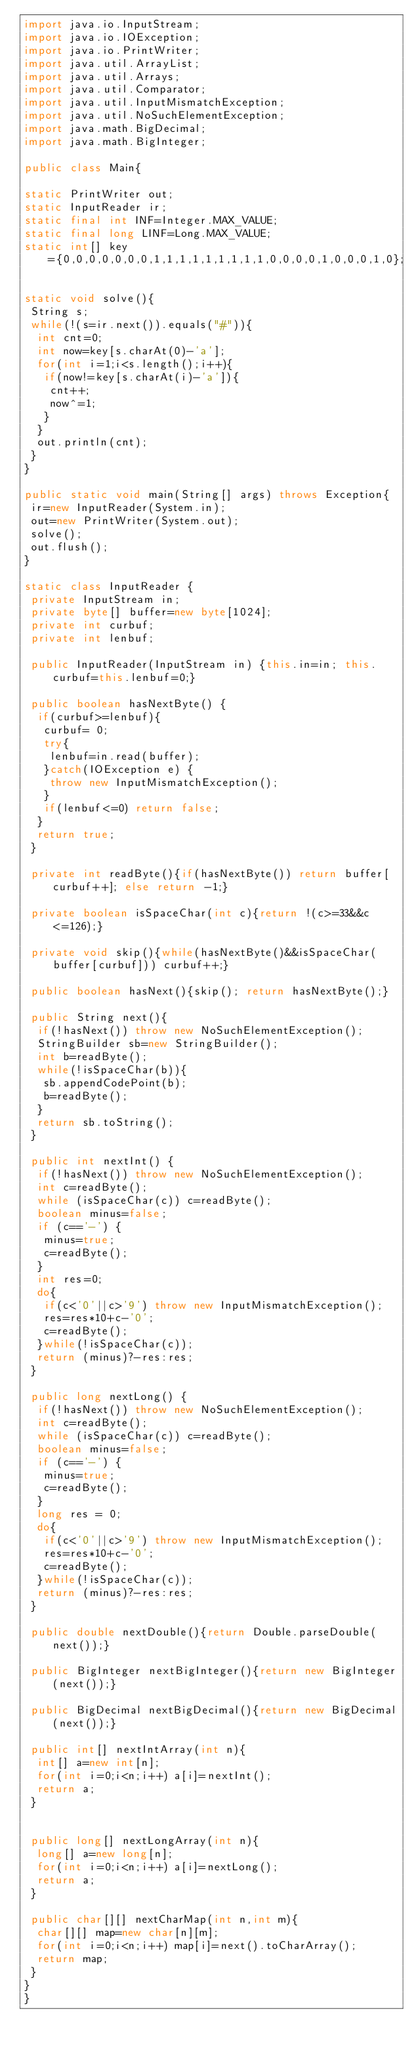Convert code to text. <code><loc_0><loc_0><loc_500><loc_500><_Java_>import java.io.InputStream;
import java.io.IOException;
import java.io.PrintWriter;
import java.util.ArrayList;
import java.util.Arrays;
import java.util.Comparator;
import java.util.InputMismatchException;
import java.util.NoSuchElementException;
import java.math.BigDecimal;
import java.math.BigInteger;
    
public class Main{
 
static PrintWriter out;
static InputReader ir;
static final int INF=Integer.MAX_VALUE;
static final long LINF=Long.MAX_VALUE;
static int[] key={0,0,0,0,0,0,0,1,1,1,1,1,1,1,1,1,0,0,0,0,1,0,0,0,1,0};
 
static void solve(){
 String s;
 while(!(s=ir.next()).equals("#")){
  int cnt=0;
  int now=key[s.charAt(0)-'a'];
  for(int i=1;i<s.length();i++){
   if(now!=key[s.charAt(i)-'a']){
    cnt++;
    now^=1;
   }
  }
  out.println(cnt);
 }
}

public static void main(String[] args) throws Exception{
 ir=new InputReader(System.in);
 out=new PrintWriter(System.out);
 solve();
 out.flush();
}

static class InputReader {
 private InputStream in;
 private byte[] buffer=new byte[1024];
 private int curbuf;
 private int lenbuf;

 public InputReader(InputStream in) {this.in=in; this.curbuf=this.lenbuf=0;}
 
 public boolean hasNextByte() {
  if(curbuf>=lenbuf){
   curbuf= 0;
   try{
    lenbuf=in.read(buffer);
   }catch(IOException e) {
    throw new InputMismatchException();
   }
   if(lenbuf<=0) return false;
  }
  return true;
 }

 private int readByte(){if(hasNextByte()) return buffer[curbuf++]; else return -1;}
 
 private boolean isSpaceChar(int c){return !(c>=33&&c<=126);}
 
 private void skip(){while(hasNextByte()&&isSpaceChar(buffer[curbuf])) curbuf++;}
 
 public boolean hasNext(){skip(); return hasNextByte();}
 
 public String next(){
  if(!hasNext()) throw new NoSuchElementException();
  StringBuilder sb=new StringBuilder();
  int b=readByte();
  while(!isSpaceChar(b)){
   sb.appendCodePoint(b);
   b=readByte();
  }
  return sb.toString();
 }
 
 public int nextInt() {
  if(!hasNext()) throw new NoSuchElementException();
  int c=readByte();
  while (isSpaceChar(c)) c=readByte();
  boolean minus=false;
  if (c=='-') {
   minus=true;
   c=readByte();
  }
  int res=0;
  do{
   if(c<'0'||c>'9') throw new InputMismatchException();
   res=res*10+c-'0';
   c=readByte();
  }while(!isSpaceChar(c));
  return (minus)?-res:res;
 }
 
 public long nextLong() {
  if(!hasNext()) throw new NoSuchElementException();
  int c=readByte();
  while (isSpaceChar(c)) c=readByte();
  boolean minus=false;
  if (c=='-') {
   minus=true;
   c=readByte();
  }
  long res = 0;
  do{
   if(c<'0'||c>'9') throw new InputMismatchException();
   res=res*10+c-'0';
   c=readByte();
  }while(!isSpaceChar(c));
  return (minus)?-res:res;
 }
 
 public double nextDouble(){return Double.parseDouble(next());}
 
 public BigInteger nextBigInteger(){return new BigInteger(next());}
 
 public BigDecimal nextBigDecimal(){return new BigDecimal(next());}
 
 public int[] nextIntArray(int n){
  int[] a=new int[n];
  for(int i=0;i<n;i++) a[i]=nextInt();
  return a;
 }
 
 
 public long[] nextLongArray(int n){
  long[] a=new long[n];
  for(int i=0;i<n;i++) a[i]=nextLong();
  return a;
 }

 public char[][] nextCharMap(int n,int m){
  char[][] map=new char[n][m];
  for(int i=0;i<n;i++) map[i]=next().toCharArray();
  return map;
 }
}
}</code> 